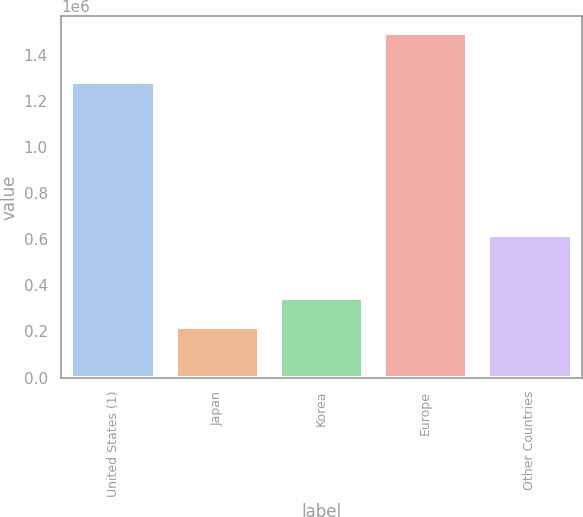Convert chart. <chart><loc_0><loc_0><loc_500><loc_500><bar_chart><fcel>United States (1)<fcel>Japan<fcel>Korea<fcel>Europe<fcel>Other Countries<nl><fcel>1.28266e+06<fcel>217667<fcel>345143<fcel>1.49243e+06<fcel>619098<nl></chart> 